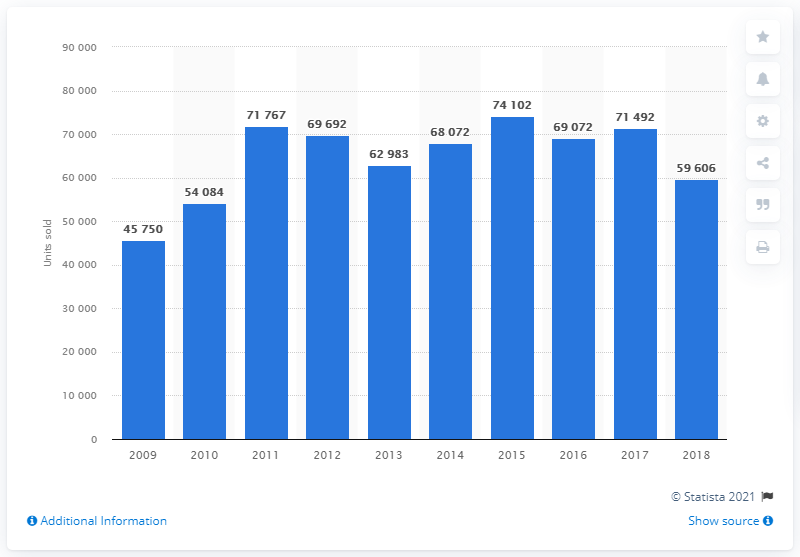Point out several critical features in this image. In 2015, Nissan sold the highest number of cars in France, which was 74,102 units. 